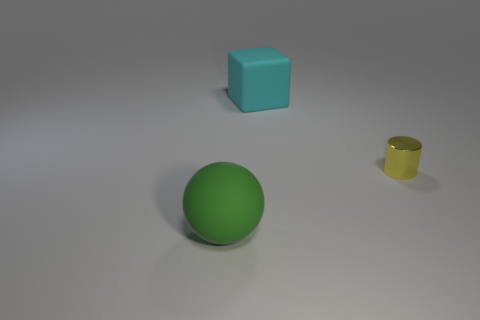Can you tell me which objects might bounce if dropped? The green ball in the image would most likely bounce if dropped, given its spherical shape and the fact that balls are typically made from materials that have elastic properties, like rubber. 